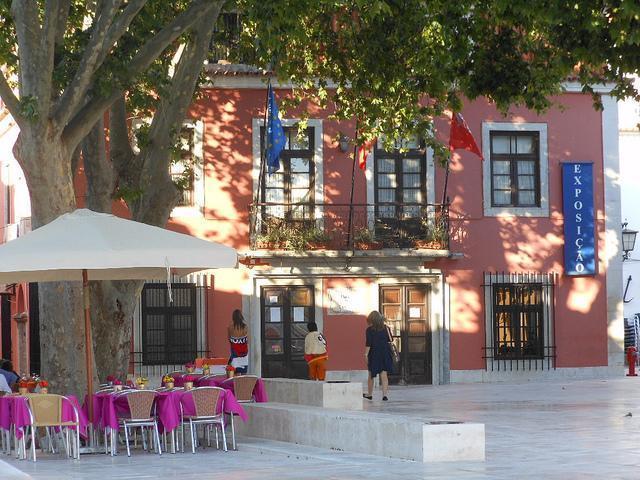What event is being held here?
Answer the question by selecting the correct answer among the 4 following choices and explain your choice with a short sentence. The answer should be formatted with the following format: `Answer: choice
Rationale: rationale.`
Options: Wedding, tractor pull, expo, jail break. Answer: expo.
Rationale: There is a sign with the expo name in it, so most likely it's a small expo out and inside. 